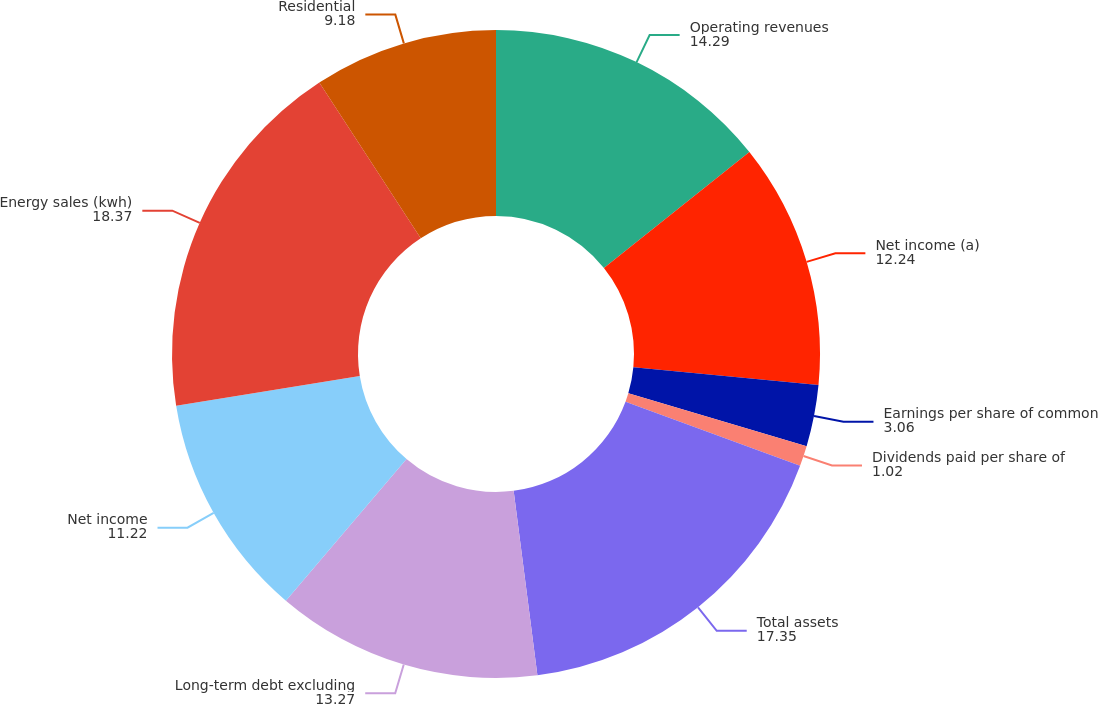Convert chart to OTSL. <chart><loc_0><loc_0><loc_500><loc_500><pie_chart><fcel>Operating revenues<fcel>Net income (a)<fcel>Earnings per share of common<fcel>Dividends paid per share of<fcel>Total assets<fcel>Long-term debt excluding<fcel>Net income<fcel>Energy sales (kwh)<fcel>Residential<nl><fcel>14.29%<fcel>12.24%<fcel>3.06%<fcel>1.02%<fcel>17.35%<fcel>13.27%<fcel>11.22%<fcel>18.37%<fcel>9.18%<nl></chart> 